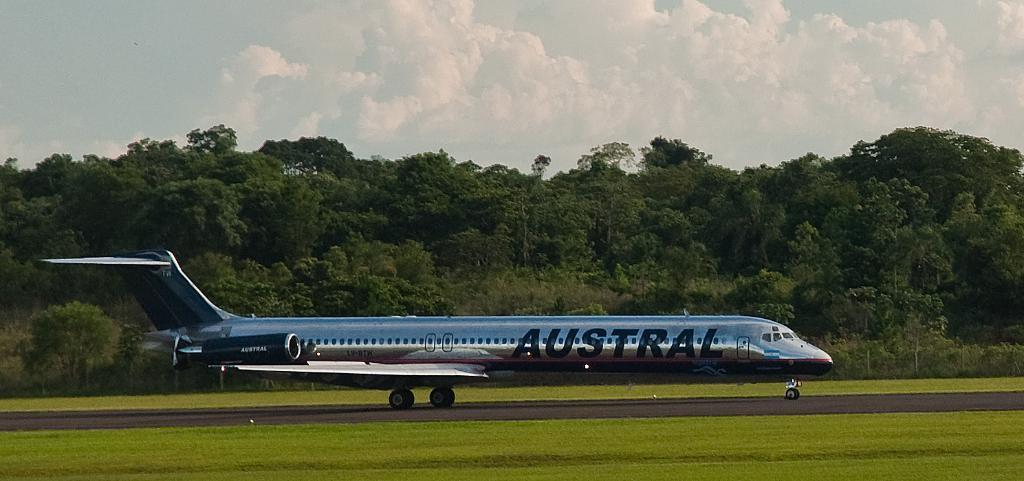<image>
Describe the image concisely. Austral is on the side of a silver plane. 